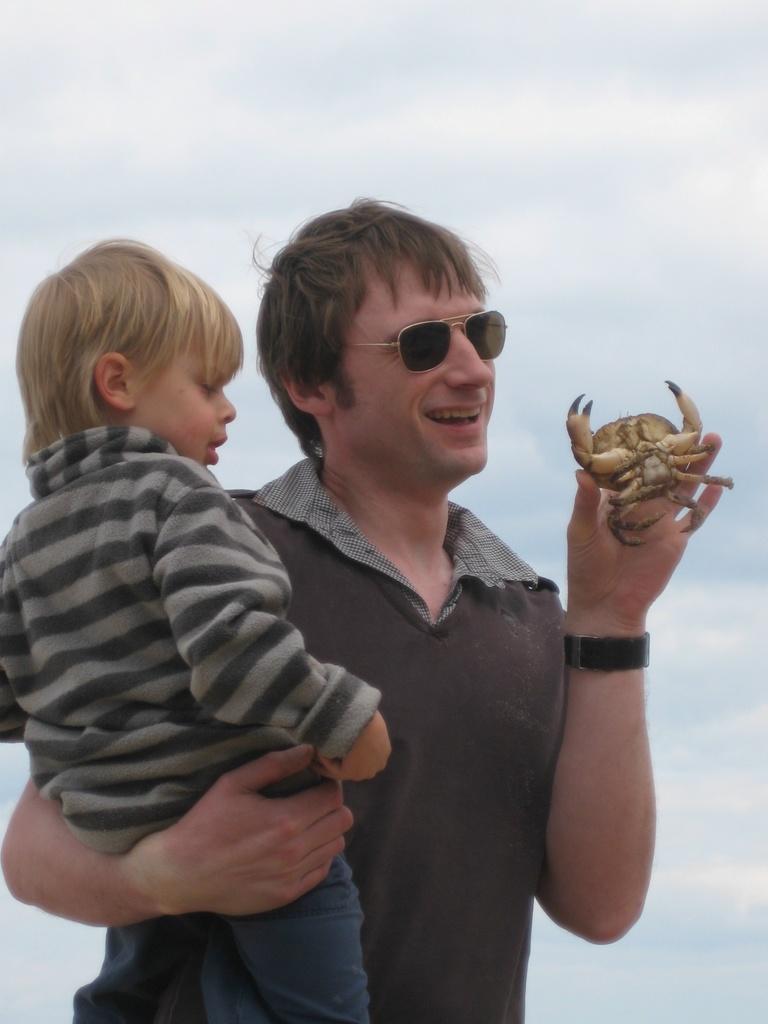Can you describe this image briefly? In the image we can see a man wearing clothes, wrist watch and he is smiling. He is holding a baby in one hand and on the other hand there is a crab. Here we can see the cloudy sky. 